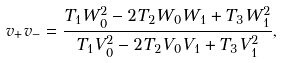Convert formula to latex. <formula><loc_0><loc_0><loc_500><loc_500>v _ { + } v _ { - } = \frac { T _ { 1 } W _ { 0 } ^ { 2 } - 2 T _ { 2 } W _ { 0 } W _ { 1 } + T _ { 3 } W _ { 1 } ^ { 2 } } { T _ { 1 } V _ { 0 } ^ { 2 } - 2 T _ { 2 } V _ { 0 } V _ { 1 } + T _ { 3 } V _ { 1 } ^ { 2 } } ,</formula> 